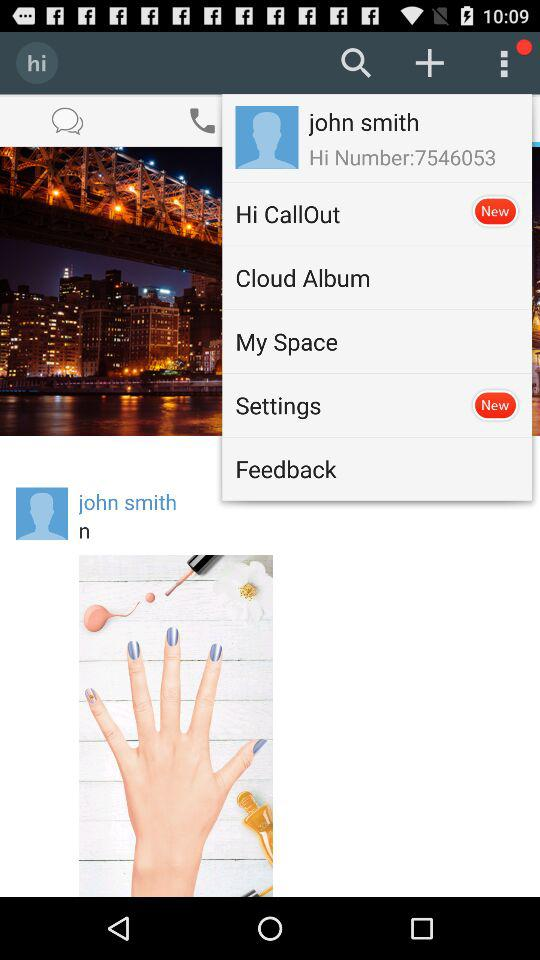What are the two new items? The two new items are "Hi CallOut" and "Settings". 